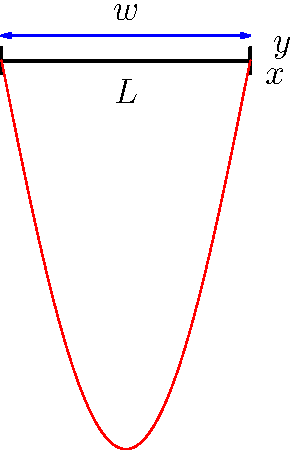In the context of wireless communication infrastructure, consider a simply supported beam representing an antenna tower subjected to uniformly distributed wind load. Given that the deflection curve is described by the equation $y = \frac{wx}{24EI}(x^3 - 2Lx^2 + L^3)$, where $w$ is the distributed load, $E$ is the modulus of elasticity, $I$ is the moment of inertia, and $L$ is the beam length, what is the maximum deflection and where does it occur? To find the maximum deflection and its location, we need to follow these steps:

1) The deflection equation is given as:
   $y = \frac{wx}{24EI}(x^3 - 2Lx^2 + L^3)$

2) To find the maximum deflection, we need to differentiate $y$ with respect to $x$ and set it to zero:
   $\frac{dy}{dx} = \frac{w}{24EI}(4x^3 - 6Lx^2 + L^3) = 0$

3) Simplify the equation:
   $4x^3 - 6Lx^2 + L^3 = 0$

4) Divide by $L^3$:
   $4(\frac{x}{L})^3 - 6(\frac{x}{L})^2 + 1 = 0$

5) Let $u = \frac{x}{L}$, then:
   $4u^3 - 6u^2 + 1 = 0$

6) This cubic equation has a solution $u = \frac{1}{2}$

7) Therefore, the maximum deflection occurs at $x = \frac{L}{2}$

8) To find the maximum deflection, substitute $x = \frac{L}{2}$ into the original equation:

   $y_{max} = \frac{w(\frac{L}{2})}{24EI}((\frac{L}{2})^3 - 2L(\frac{L}{2})^2 + L^3)$
   
   $= \frac{wL}{48EI}(\frac{L^3}{8} - \frac{L^3}{2} + L^3)$
   
   $= \frac{wL}{48EI}(\frac{5L^3}{8})$
   
   $= \frac{5wL^4}{384EI}$

Therefore, the maximum deflection is $\frac{5wL^4}{384EI}$ and it occurs at the midpoint of the beam ($x = \frac{L}{2}$).
Answer: Maximum deflection: $\frac{5wL^4}{384EI}$ at $x = \frac{L}{2}$ 